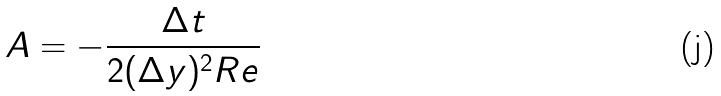Convert formula to latex. <formula><loc_0><loc_0><loc_500><loc_500>A = - \frac { \Delta t } { 2 ( \Delta y ) ^ { 2 } R e }</formula> 